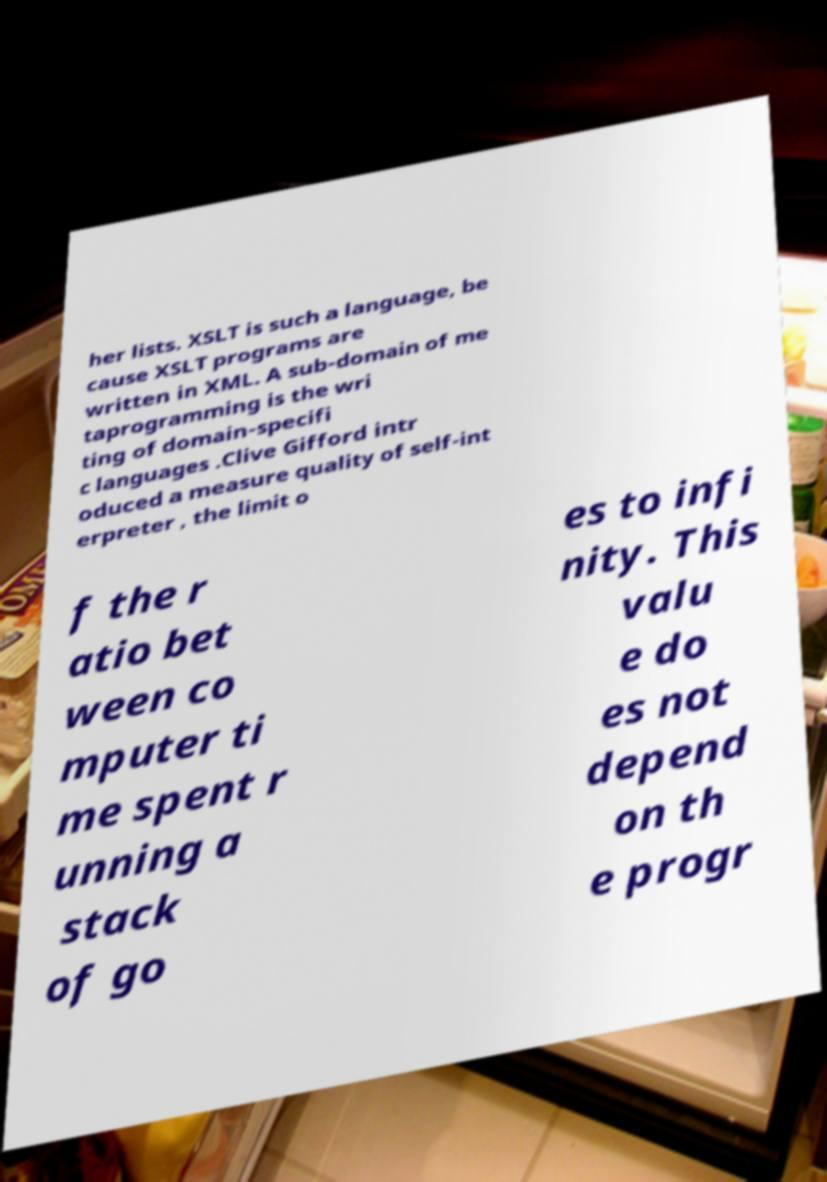Please read and relay the text visible in this image. What does it say? her lists. XSLT is such a language, be cause XSLT programs are written in XML. A sub-domain of me taprogramming is the wri ting of domain-specifi c languages .Clive Gifford intr oduced a measure quality of self-int erpreter , the limit o f the r atio bet ween co mputer ti me spent r unning a stack of go es to infi nity. This valu e do es not depend on th e progr 